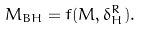Convert formula to latex. <formula><loc_0><loc_0><loc_500><loc_500>M _ { B H } = f ( M , \delta _ { H } ^ { R } ) .</formula> 